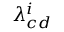<formula> <loc_0><loc_0><loc_500><loc_500>\lambda _ { c d } ^ { i }</formula> 